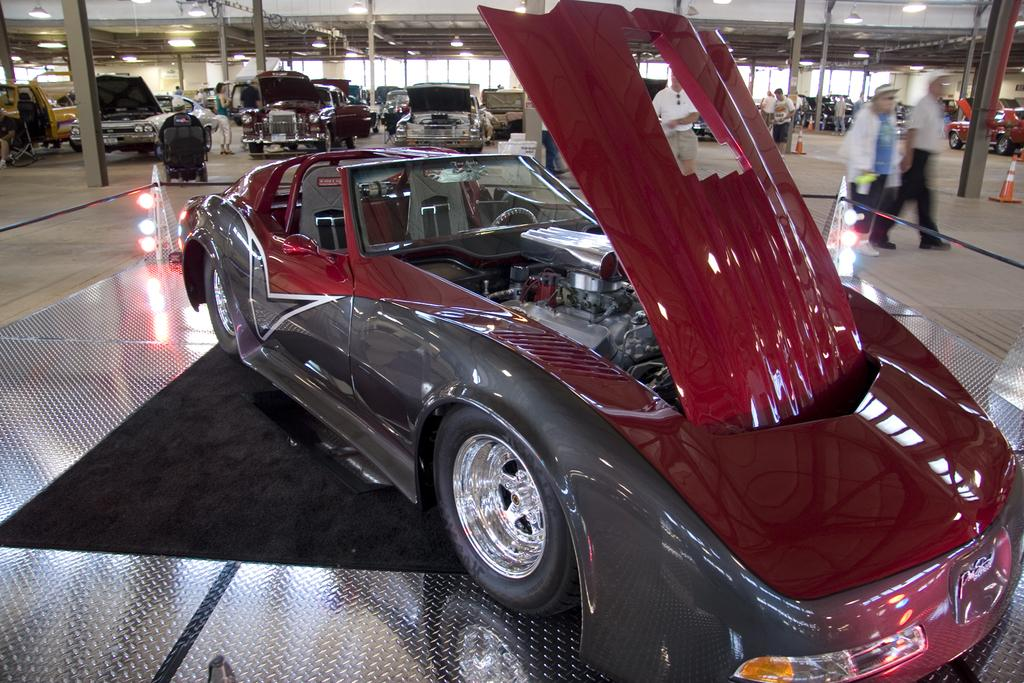What objects are on the floor in the image? There are vehicles on the floor in the image. What are the people in the image doing? The people in the image are standing and walking on the floor. What can be seen above the floor in the image? There is a ceiling with lights in the image. What type of vegetable is being used as a decoration in the image? There is no vegetable present in the image for decoration. How does the temper of the people in the image change throughout the scene? The provided facts do not give any information about the temper of the people in the image. 